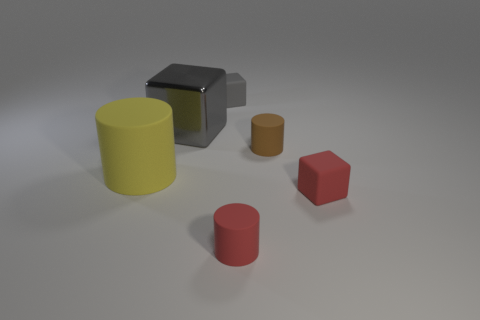What can these objects tell us about the material they're resting on? The objects' crisp and defined shadows indicate that the surface they're resting on is smooth and matte. There's no visible distortion, suggesting it's also quite rigid and flat. 